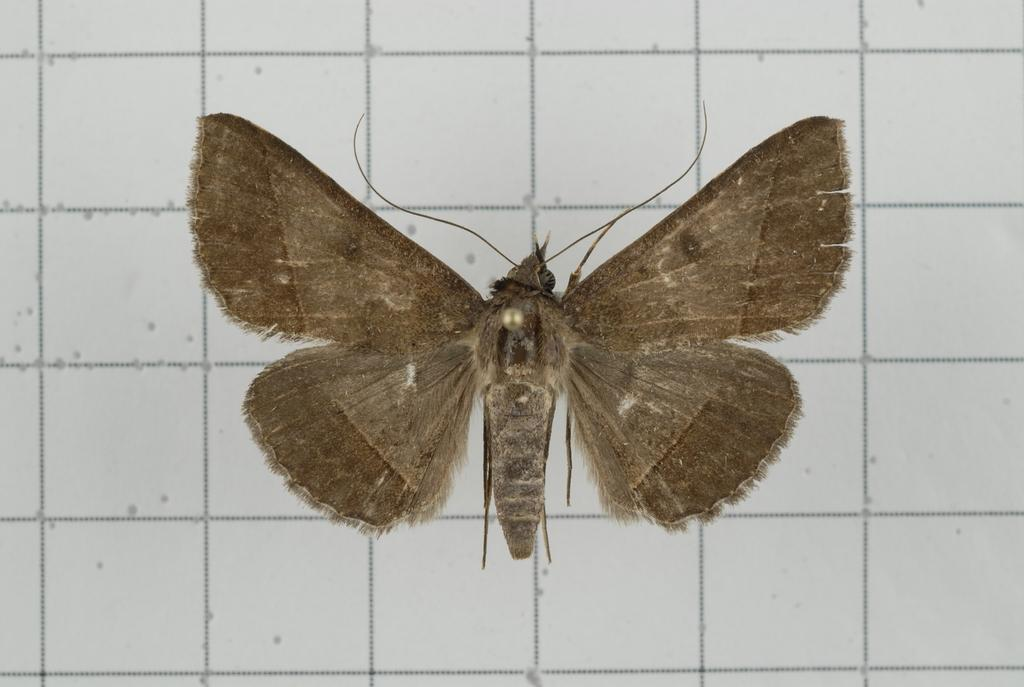What type of creature can be seen in the image? There is a butterfly in the image. What can be seen in the background of the image? There are tiles visible in the background of the image. What type of friction can be observed between the butterfly's wings and the tiles in the image? There is no friction between the butterfly's wings and the tiles in the image, as the butterfly is likely not in contact with the tiles. 